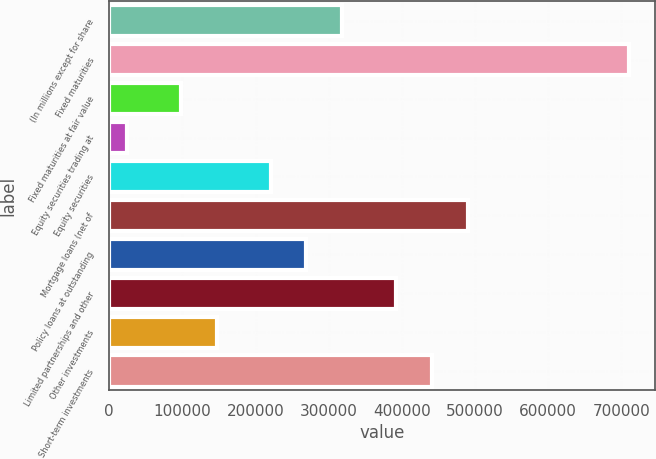Convert chart. <chart><loc_0><loc_0><loc_500><loc_500><bar_chart><fcel>(In millions except for share<fcel>Fixed maturities<fcel>Fixed maturities at fair value<fcel>Equity securities trading at<fcel>Equity securities<fcel>Mortgage loans (net of<fcel>Policy loans at outstanding<fcel>Limited partnerships and other<fcel>Other investments<fcel>Short-term investments<nl><fcel>318515<fcel>710528<fcel>98008.2<fcel>24505.8<fcel>220512<fcel>490021<fcel>269514<fcel>392018<fcel>147010<fcel>441019<nl></chart> 